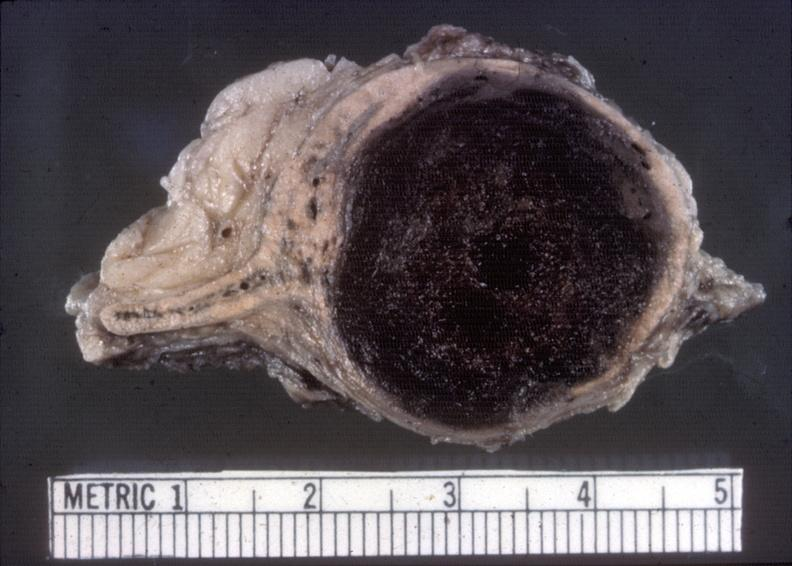s endocrine present?
Answer the question using a single word or phrase. Yes 